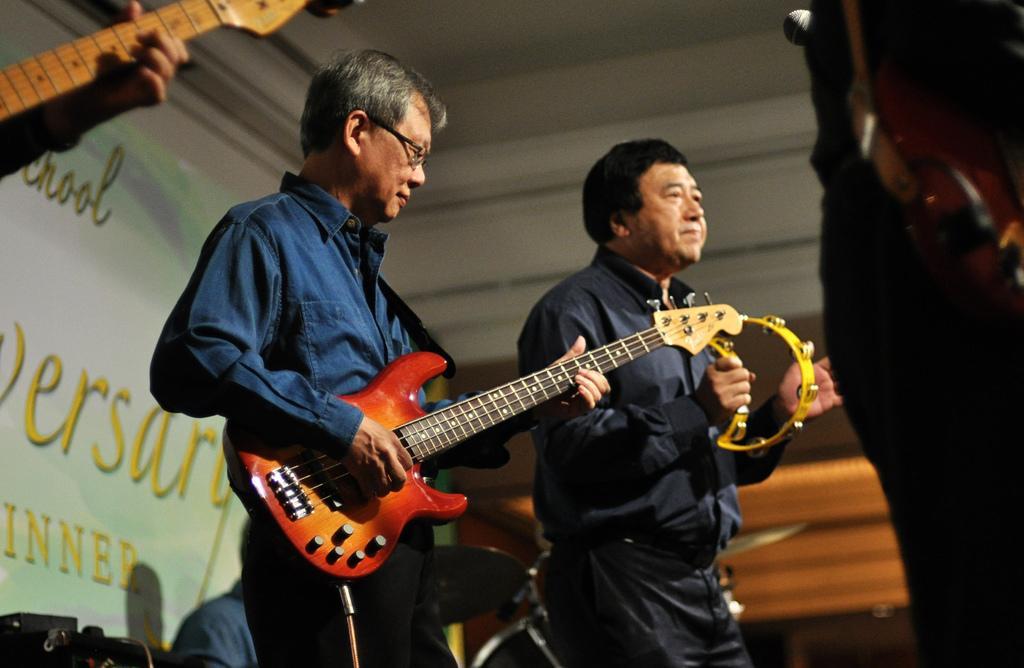How would you summarize this image in a sentence or two? In this image, In the middle there are some people standing and holding the music instruments, In the left side there is a white color poster and white color roof and wall. 